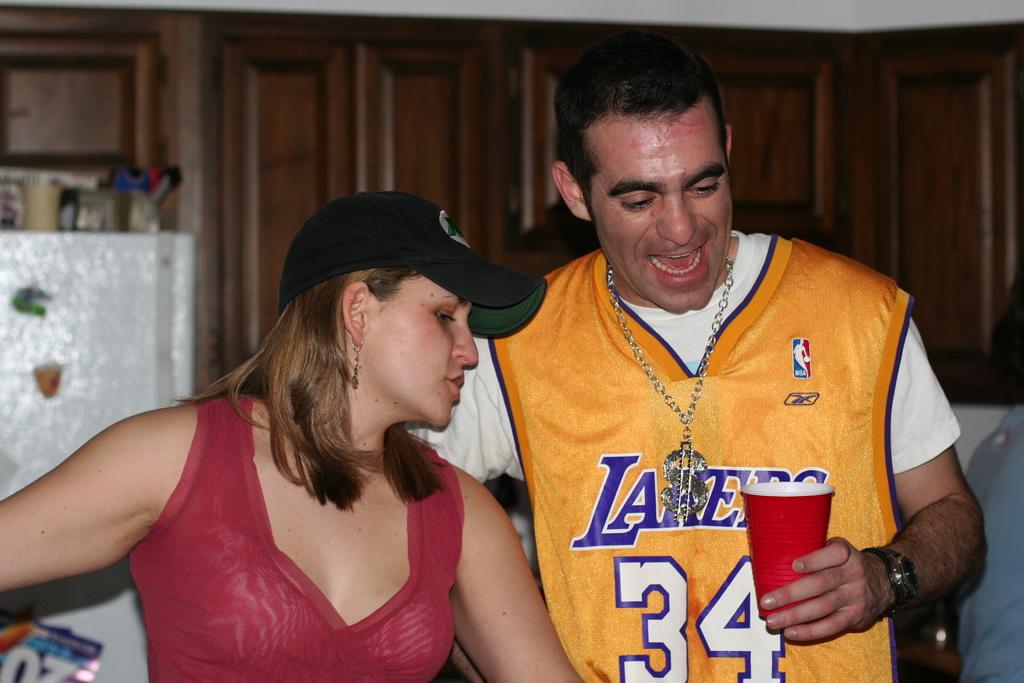What number is on his jersey?
Provide a succinct answer. 34. What team is he wearing?
Your response must be concise. Lakers. 